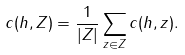Convert formula to latex. <formula><loc_0><loc_0><loc_500><loc_500>c ( h , Z ) = \frac { 1 } { | Z | } \sum _ { z \in Z } c ( h , z ) .</formula> 